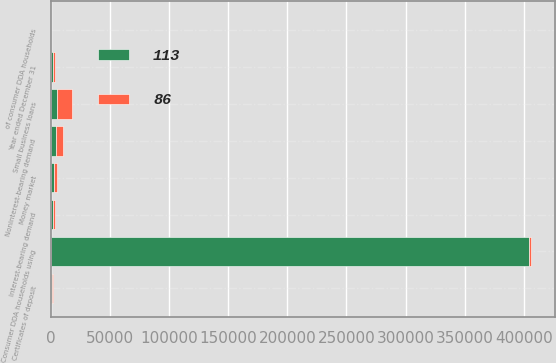Convert chart. <chart><loc_0><loc_0><loc_500><loc_500><stacked_bar_chart><ecel><fcel>Year ended December 31<fcel>Consumer DDA households using<fcel>of consumer DDA households<fcel>Small business loans<fcel>Noninterest-bearing demand<fcel>Interest-bearing demand<fcel>Money market<fcel>Certificates of deposit<nl><fcel>86<fcel>2007<fcel>2007<fcel>33<fcel>13049<fcel>5994<fcel>1873<fcel>3152<fcel>1068<nl><fcel>113<fcel>2006<fcel>404000<fcel>23<fcel>5116<fcel>4383<fcel>1649<fcel>2592<fcel>802<nl></chart> 